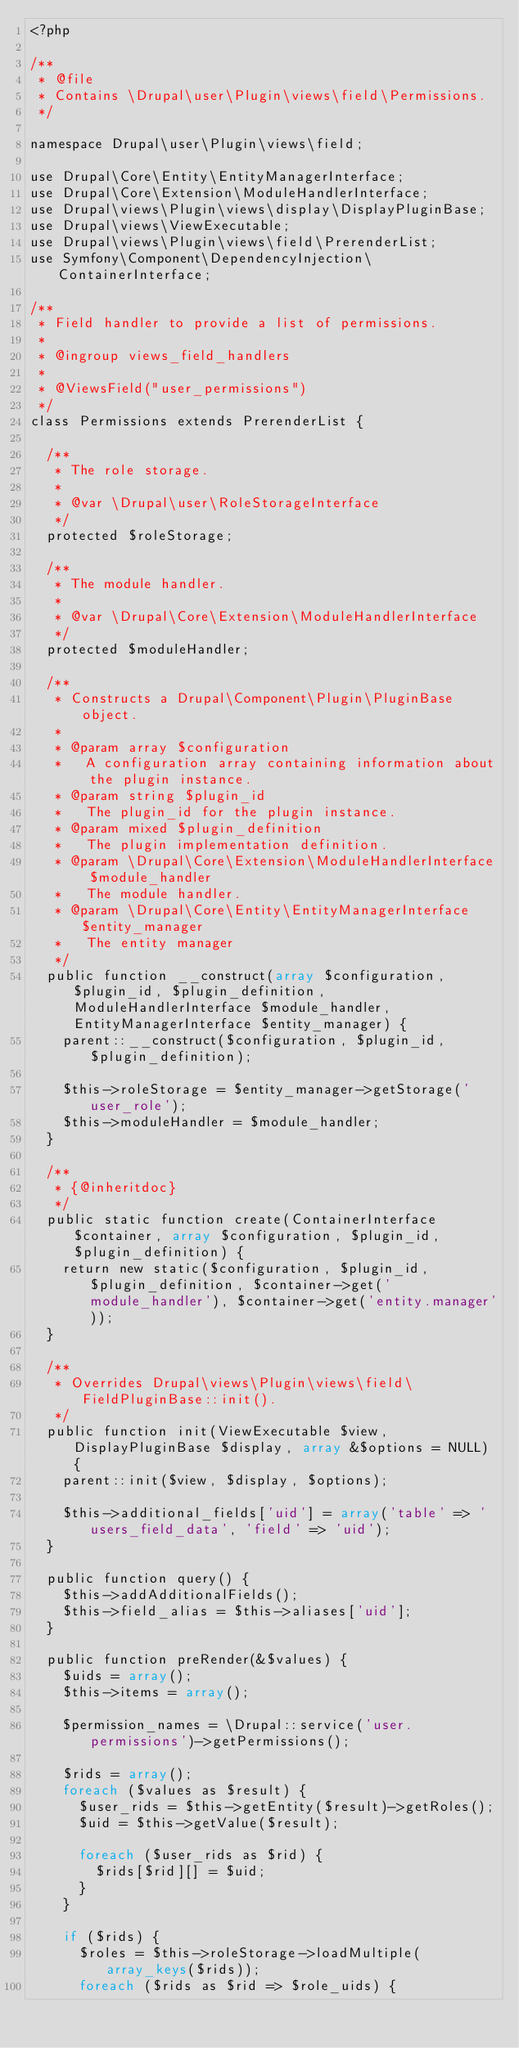Convert code to text. <code><loc_0><loc_0><loc_500><loc_500><_PHP_><?php

/**
 * @file
 * Contains \Drupal\user\Plugin\views\field\Permissions.
 */

namespace Drupal\user\Plugin\views\field;

use Drupal\Core\Entity\EntityManagerInterface;
use Drupal\Core\Extension\ModuleHandlerInterface;
use Drupal\views\Plugin\views\display\DisplayPluginBase;
use Drupal\views\ViewExecutable;
use Drupal\views\Plugin\views\field\PrerenderList;
use Symfony\Component\DependencyInjection\ContainerInterface;

/**
 * Field handler to provide a list of permissions.
 *
 * @ingroup views_field_handlers
 *
 * @ViewsField("user_permissions")
 */
class Permissions extends PrerenderList {

  /**
   * The role storage.
   *
   * @var \Drupal\user\RoleStorageInterface
   */
  protected $roleStorage;

  /**
   * The module handler.
   *
   * @var \Drupal\Core\Extension\ModuleHandlerInterface
   */
  protected $moduleHandler;

  /**
   * Constructs a Drupal\Component\Plugin\PluginBase object.
   *
   * @param array $configuration
   *   A configuration array containing information about the plugin instance.
   * @param string $plugin_id
   *   The plugin_id for the plugin instance.
   * @param mixed $plugin_definition
   *   The plugin implementation definition.
   * @param \Drupal\Core\Extension\ModuleHandlerInterface $module_handler
   *   The module handler.
   * @param \Drupal\Core\Entity\EntityManagerInterface $entity_manager
   *   The entity manager
   */
  public function __construct(array $configuration, $plugin_id, $plugin_definition, ModuleHandlerInterface $module_handler, EntityManagerInterface $entity_manager) {
    parent::__construct($configuration, $plugin_id, $plugin_definition);

    $this->roleStorage = $entity_manager->getStorage('user_role');
    $this->moduleHandler = $module_handler;
  }

  /**
   * {@inheritdoc}
   */
  public static function create(ContainerInterface $container, array $configuration, $plugin_id, $plugin_definition) {
    return new static($configuration, $plugin_id, $plugin_definition, $container->get('module_handler'), $container->get('entity.manager'));
  }

  /**
   * Overrides Drupal\views\Plugin\views\field\FieldPluginBase::init().
   */
  public function init(ViewExecutable $view, DisplayPluginBase $display, array &$options = NULL) {
    parent::init($view, $display, $options);

    $this->additional_fields['uid'] = array('table' => 'users_field_data', 'field' => 'uid');
  }

  public function query() {
    $this->addAdditionalFields();
    $this->field_alias = $this->aliases['uid'];
  }

  public function preRender(&$values) {
    $uids = array();
    $this->items = array();

    $permission_names = \Drupal::service('user.permissions')->getPermissions();

    $rids = array();
    foreach ($values as $result) {
      $user_rids = $this->getEntity($result)->getRoles();
      $uid = $this->getValue($result);

      foreach ($user_rids as $rid) {
        $rids[$rid][] = $uid;
      }
    }

    if ($rids) {
      $roles = $this->roleStorage->loadMultiple(array_keys($rids));
      foreach ($rids as $rid => $role_uids) {</code> 